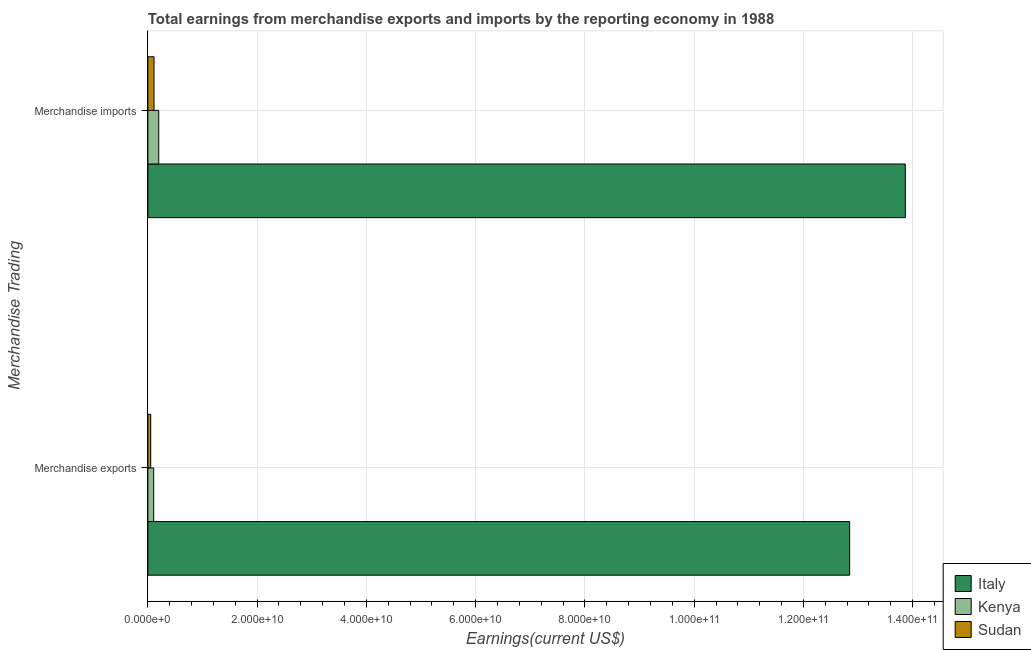Are the number of bars per tick equal to the number of legend labels?
Provide a succinct answer. Yes. Are the number of bars on each tick of the Y-axis equal?
Keep it short and to the point. Yes. How many bars are there on the 2nd tick from the top?
Offer a terse response. 3. How many bars are there on the 1st tick from the bottom?
Offer a terse response. 3. What is the label of the 1st group of bars from the top?
Provide a short and direct response. Merchandise imports. What is the earnings from merchandise exports in Sudan?
Offer a very short reply. 5.26e+08. Across all countries, what is the maximum earnings from merchandise exports?
Your response must be concise. 1.28e+11. Across all countries, what is the minimum earnings from merchandise exports?
Ensure brevity in your answer.  5.26e+08. In which country was the earnings from merchandise imports maximum?
Your response must be concise. Italy. In which country was the earnings from merchandise exports minimum?
Your response must be concise. Sudan. What is the total earnings from merchandise imports in the graph?
Offer a terse response. 1.42e+11. What is the difference between the earnings from merchandise imports in Kenya and that in Sudan?
Make the answer very short. 8.61e+08. What is the difference between the earnings from merchandise imports in Kenya and the earnings from merchandise exports in Sudan?
Your response must be concise. 1.46e+09. What is the average earnings from merchandise exports per country?
Give a very brief answer. 4.34e+1. What is the difference between the earnings from merchandise imports and earnings from merchandise exports in Kenya?
Make the answer very short. 9.23e+08. What is the ratio of the earnings from merchandise exports in Italy to that in Kenya?
Ensure brevity in your answer.  120.49. Is the earnings from merchandise imports in Sudan less than that in Kenya?
Make the answer very short. Yes. What does the 1st bar from the top in Merchandise imports represents?
Ensure brevity in your answer.  Sudan. Are all the bars in the graph horizontal?
Your answer should be compact. Yes. What is the difference between two consecutive major ticks on the X-axis?
Offer a terse response. 2.00e+1. Are the values on the major ticks of X-axis written in scientific E-notation?
Provide a succinct answer. Yes. Does the graph contain any zero values?
Your answer should be compact. No. Does the graph contain grids?
Offer a terse response. Yes. What is the title of the graph?
Make the answer very short. Total earnings from merchandise exports and imports by the reporting economy in 1988. What is the label or title of the X-axis?
Keep it short and to the point. Earnings(current US$). What is the label or title of the Y-axis?
Your answer should be compact. Merchandise Trading. What is the Earnings(current US$) in Italy in Merchandise exports?
Offer a terse response. 1.28e+11. What is the Earnings(current US$) in Kenya in Merchandise exports?
Provide a short and direct response. 1.07e+09. What is the Earnings(current US$) of Sudan in Merchandise exports?
Ensure brevity in your answer.  5.26e+08. What is the Earnings(current US$) in Italy in Merchandise imports?
Provide a succinct answer. 1.39e+11. What is the Earnings(current US$) in Kenya in Merchandise imports?
Give a very brief answer. 1.99e+09. What is the Earnings(current US$) in Sudan in Merchandise imports?
Make the answer very short. 1.13e+09. Across all Merchandise Trading, what is the maximum Earnings(current US$) in Italy?
Your answer should be compact. 1.39e+11. Across all Merchandise Trading, what is the maximum Earnings(current US$) in Kenya?
Offer a terse response. 1.99e+09. Across all Merchandise Trading, what is the maximum Earnings(current US$) of Sudan?
Offer a terse response. 1.13e+09. Across all Merchandise Trading, what is the minimum Earnings(current US$) of Italy?
Make the answer very short. 1.28e+11. Across all Merchandise Trading, what is the minimum Earnings(current US$) in Kenya?
Your response must be concise. 1.07e+09. Across all Merchandise Trading, what is the minimum Earnings(current US$) in Sudan?
Your response must be concise. 5.26e+08. What is the total Earnings(current US$) in Italy in the graph?
Your answer should be very brief. 2.67e+11. What is the total Earnings(current US$) in Kenya in the graph?
Keep it short and to the point. 3.05e+09. What is the total Earnings(current US$) in Sudan in the graph?
Offer a terse response. 1.65e+09. What is the difference between the Earnings(current US$) in Italy in Merchandise exports and that in Merchandise imports?
Your answer should be very brief. -1.02e+1. What is the difference between the Earnings(current US$) in Kenya in Merchandise exports and that in Merchandise imports?
Give a very brief answer. -9.23e+08. What is the difference between the Earnings(current US$) of Sudan in Merchandise exports and that in Merchandise imports?
Your answer should be very brief. -6.02e+08. What is the difference between the Earnings(current US$) in Italy in Merchandise exports and the Earnings(current US$) in Kenya in Merchandise imports?
Your answer should be compact. 1.26e+11. What is the difference between the Earnings(current US$) in Italy in Merchandise exports and the Earnings(current US$) in Sudan in Merchandise imports?
Offer a terse response. 1.27e+11. What is the difference between the Earnings(current US$) of Kenya in Merchandise exports and the Earnings(current US$) of Sudan in Merchandise imports?
Provide a succinct answer. -6.17e+07. What is the average Earnings(current US$) in Italy per Merchandise Trading?
Ensure brevity in your answer.  1.34e+11. What is the average Earnings(current US$) of Kenya per Merchandise Trading?
Ensure brevity in your answer.  1.53e+09. What is the average Earnings(current US$) in Sudan per Merchandise Trading?
Offer a very short reply. 8.27e+08. What is the difference between the Earnings(current US$) in Italy and Earnings(current US$) in Kenya in Merchandise exports?
Offer a very short reply. 1.27e+11. What is the difference between the Earnings(current US$) in Italy and Earnings(current US$) in Sudan in Merchandise exports?
Ensure brevity in your answer.  1.28e+11. What is the difference between the Earnings(current US$) in Kenya and Earnings(current US$) in Sudan in Merchandise exports?
Ensure brevity in your answer.  5.40e+08. What is the difference between the Earnings(current US$) of Italy and Earnings(current US$) of Kenya in Merchandise imports?
Ensure brevity in your answer.  1.37e+11. What is the difference between the Earnings(current US$) in Italy and Earnings(current US$) in Sudan in Merchandise imports?
Offer a terse response. 1.38e+11. What is the difference between the Earnings(current US$) of Kenya and Earnings(current US$) of Sudan in Merchandise imports?
Offer a very short reply. 8.61e+08. What is the ratio of the Earnings(current US$) in Italy in Merchandise exports to that in Merchandise imports?
Your response must be concise. 0.93. What is the ratio of the Earnings(current US$) of Kenya in Merchandise exports to that in Merchandise imports?
Provide a short and direct response. 0.54. What is the ratio of the Earnings(current US$) of Sudan in Merchandise exports to that in Merchandise imports?
Offer a very short reply. 0.47. What is the difference between the highest and the second highest Earnings(current US$) in Italy?
Ensure brevity in your answer.  1.02e+1. What is the difference between the highest and the second highest Earnings(current US$) in Kenya?
Your answer should be compact. 9.23e+08. What is the difference between the highest and the second highest Earnings(current US$) in Sudan?
Provide a short and direct response. 6.02e+08. What is the difference between the highest and the lowest Earnings(current US$) of Italy?
Offer a very short reply. 1.02e+1. What is the difference between the highest and the lowest Earnings(current US$) in Kenya?
Your response must be concise. 9.23e+08. What is the difference between the highest and the lowest Earnings(current US$) of Sudan?
Your answer should be very brief. 6.02e+08. 